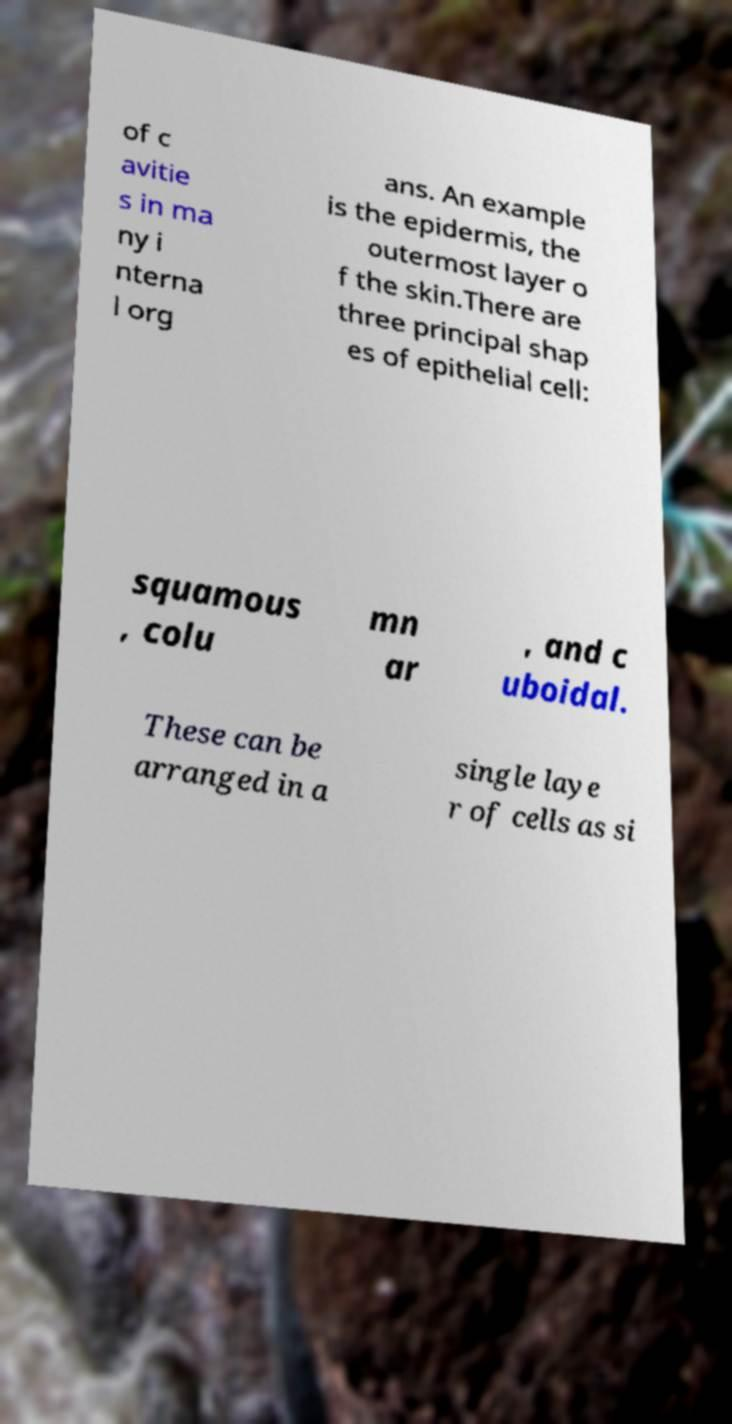Can you accurately transcribe the text from the provided image for me? of c avitie s in ma ny i nterna l org ans. An example is the epidermis, the outermost layer o f the skin.There are three principal shap es of epithelial cell: squamous , colu mn ar , and c uboidal. These can be arranged in a single laye r of cells as si 